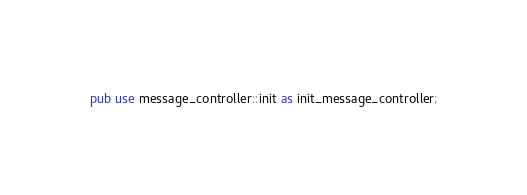Convert code to text. <code><loc_0><loc_0><loc_500><loc_500><_Rust_>pub use message_controller::init as init_message_controller;</code> 